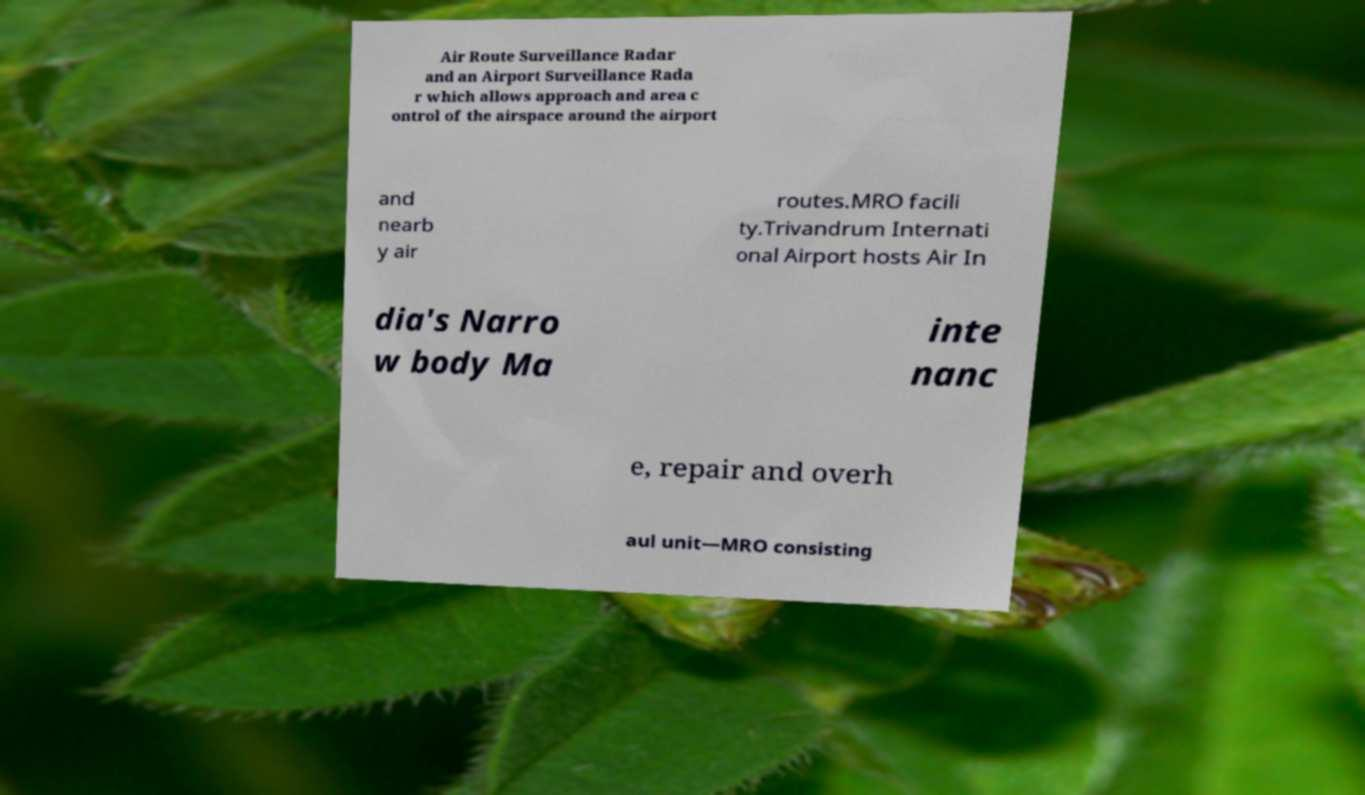There's text embedded in this image that I need extracted. Can you transcribe it verbatim? Air Route Surveillance Radar and an Airport Surveillance Rada r which allows approach and area c ontrol of the airspace around the airport and nearb y air routes.MRO facili ty.Trivandrum Internati onal Airport hosts Air In dia's Narro w body Ma inte nanc e, repair and overh aul unit—MRO consisting 